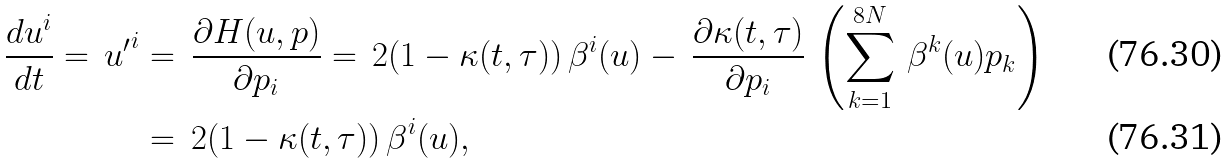<formula> <loc_0><loc_0><loc_500><loc_500>\frac { d u ^ { i } } { d t } = \, { u ^ { \prime } } ^ { i } & = \, \frac { \partial H ( u , p ) } { \partial p _ { i } } = \, 2 ( 1 - \kappa ( t , \tau ) ) \, \beta ^ { i } ( u ) - \, \frac { \partial \kappa ( t , \tau ) } { \partial p _ { i } } \, \left ( \sum ^ { 8 N } _ { k = 1 } \, \beta ^ { k } ( u ) p _ { k } \right ) \\ & = \, 2 ( 1 - \kappa ( t , \tau ) ) \, \beta ^ { i } ( u ) ,</formula> 